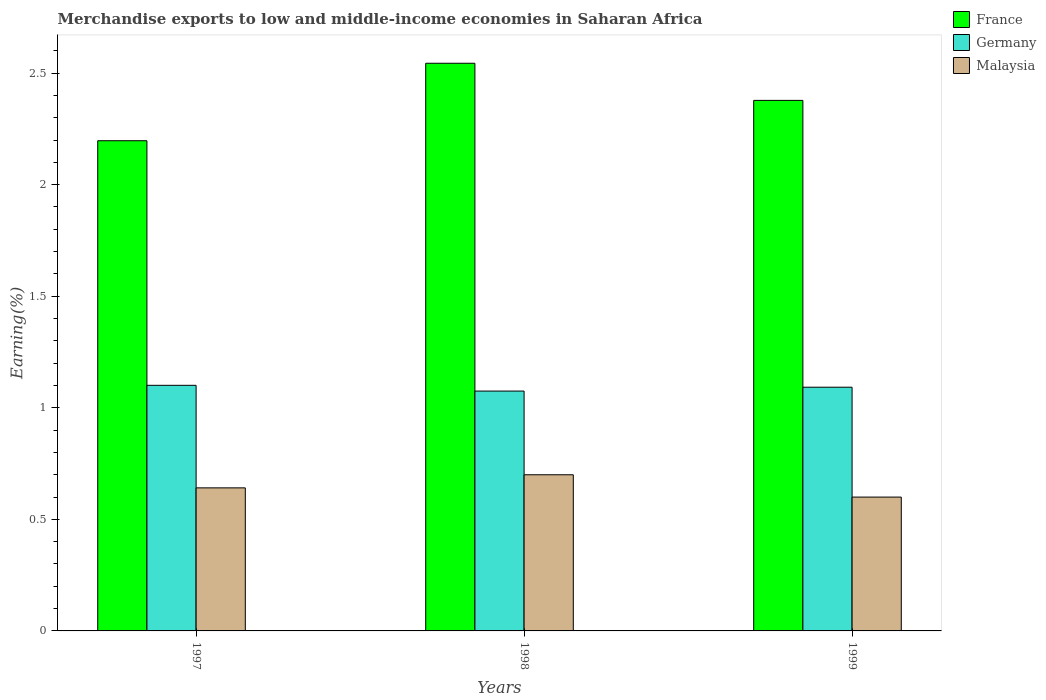How many different coloured bars are there?
Provide a succinct answer. 3. How many groups of bars are there?
Offer a very short reply. 3. Are the number of bars per tick equal to the number of legend labels?
Provide a succinct answer. Yes. How many bars are there on the 2nd tick from the right?
Make the answer very short. 3. What is the label of the 1st group of bars from the left?
Offer a terse response. 1997. What is the percentage of amount earned from merchandise exports in Malaysia in 1999?
Give a very brief answer. 0.6. Across all years, what is the maximum percentage of amount earned from merchandise exports in Malaysia?
Make the answer very short. 0.7. Across all years, what is the minimum percentage of amount earned from merchandise exports in France?
Your answer should be compact. 2.2. In which year was the percentage of amount earned from merchandise exports in Malaysia maximum?
Provide a succinct answer. 1998. In which year was the percentage of amount earned from merchandise exports in Germany minimum?
Your response must be concise. 1998. What is the total percentage of amount earned from merchandise exports in Germany in the graph?
Provide a short and direct response. 3.27. What is the difference between the percentage of amount earned from merchandise exports in Malaysia in 1997 and that in 1998?
Offer a very short reply. -0.06. What is the difference between the percentage of amount earned from merchandise exports in Germany in 1998 and the percentage of amount earned from merchandise exports in Malaysia in 1999?
Ensure brevity in your answer.  0.48. What is the average percentage of amount earned from merchandise exports in France per year?
Give a very brief answer. 2.37. In the year 1997, what is the difference between the percentage of amount earned from merchandise exports in Malaysia and percentage of amount earned from merchandise exports in France?
Your response must be concise. -1.56. What is the ratio of the percentage of amount earned from merchandise exports in France in 1997 to that in 1999?
Your response must be concise. 0.92. Is the percentage of amount earned from merchandise exports in Germany in 1997 less than that in 1999?
Ensure brevity in your answer.  No. What is the difference between the highest and the second highest percentage of amount earned from merchandise exports in Malaysia?
Provide a succinct answer. 0.06. What is the difference between the highest and the lowest percentage of amount earned from merchandise exports in France?
Your response must be concise. 0.35. What does the 3rd bar from the left in 1999 represents?
Your response must be concise. Malaysia. What does the 1st bar from the right in 1997 represents?
Give a very brief answer. Malaysia. Is it the case that in every year, the sum of the percentage of amount earned from merchandise exports in Germany and percentage of amount earned from merchandise exports in France is greater than the percentage of amount earned from merchandise exports in Malaysia?
Give a very brief answer. Yes. How are the legend labels stacked?
Give a very brief answer. Vertical. What is the title of the graph?
Your response must be concise. Merchandise exports to low and middle-income economies in Saharan Africa. Does "Panama" appear as one of the legend labels in the graph?
Your response must be concise. No. What is the label or title of the Y-axis?
Your answer should be compact. Earning(%). What is the Earning(%) in France in 1997?
Your response must be concise. 2.2. What is the Earning(%) in Germany in 1997?
Give a very brief answer. 1.1. What is the Earning(%) in Malaysia in 1997?
Your answer should be compact. 0.64. What is the Earning(%) of France in 1998?
Offer a terse response. 2.54. What is the Earning(%) of Germany in 1998?
Ensure brevity in your answer.  1.07. What is the Earning(%) of Malaysia in 1998?
Offer a very short reply. 0.7. What is the Earning(%) of France in 1999?
Make the answer very short. 2.38. What is the Earning(%) of Germany in 1999?
Provide a succinct answer. 1.09. What is the Earning(%) in Malaysia in 1999?
Provide a short and direct response. 0.6. Across all years, what is the maximum Earning(%) of France?
Your answer should be compact. 2.54. Across all years, what is the maximum Earning(%) in Germany?
Keep it short and to the point. 1.1. Across all years, what is the maximum Earning(%) in Malaysia?
Your response must be concise. 0.7. Across all years, what is the minimum Earning(%) of France?
Offer a terse response. 2.2. Across all years, what is the minimum Earning(%) of Germany?
Your answer should be very brief. 1.07. Across all years, what is the minimum Earning(%) of Malaysia?
Make the answer very short. 0.6. What is the total Earning(%) of France in the graph?
Ensure brevity in your answer.  7.12. What is the total Earning(%) in Germany in the graph?
Your response must be concise. 3.27. What is the total Earning(%) in Malaysia in the graph?
Your answer should be compact. 1.94. What is the difference between the Earning(%) of France in 1997 and that in 1998?
Keep it short and to the point. -0.35. What is the difference between the Earning(%) in Germany in 1997 and that in 1998?
Provide a short and direct response. 0.03. What is the difference between the Earning(%) in Malaysia in 1997 and that in 1998?
Offer a terse response. -0.06. What is the difference between the Earning(%) of France in 1997 and that in 1999?
Give a very brief answer. -0.18. What is the difference between the Earning(%) in Germany in 1997 and that in 1999?
Your answer should be compact. 0.01. What is the difference between the Earning(%) in Malaysia in 1997 and that in 1999?
Offer a terse response. 0.04. What is the difference between the Earning(%) of France in 1998 and that in 1999?
Offer a very short reply. 0.17. What is the difference between the Earning(%) in Germany in 1998 and that in 1999?
Provide a succinct answer. -0.02. What is the difference between the Earning(%) of Malaysia in 1998 and that in 1999?
Your answer should be compact. 0.1. What is the difference between the Earning(%) in France in 1997 and the Earning(%) in Germany in 1998?
Give a very brief answer. 1.12. What is the difference between the Earning(%) in France in 1997 and the Earning(%) in Malaysia in 1998?
Provide a short and direct response. 1.5. What is the difference between the Earning(%) of Germany in 1997 and the Earning(%) of Malaysia in 1998?
Keep it short and to the point. 0.4. What is the difference between the Earning(%) of France in 1997 and the Earning(%) of Germany in 1999?
Ensure brevity in your answer.  1.1. What is the difference between the Earning(%) in France in 1997 and the Earning(%) in Malaysia in 1999?
Make the answer very short. 1.6. What is the difference between the Earning(%) of Germany in 1997 and the Earning(%) of Malaysia in 1999?
Offer a terse response. 0.5. What is the difference between the Earning(%) of France in 1998 and the Earning(%) of Germany in 1999?
Ensure brevity in your answer.  1.45. What is the difference between the Earning(%) in France in 1998 and the Earning(%) in Malaysia in 1999?
Your answer should be very brief. 1.94. What is the difference between the Earning(%) in Germany in 1998 and the Earning(%) in Malaysia in 1999?
Give a very brief answer. 0.48. What is the average Earning(%) in France per year?
Provide a succinct answer. 2.37. What is the average Earning(%) of Germany per year?
Give a very brief answer. 1.09. What is the average Earning(%) in Malaysia per year?
Your response must be concise. 0.65. In the year 1997, what is the difference between the Earning(%) in France and Earning(%) in Germany?
Provide a short and direct response. 1.1. In the year 1997, what is the difference between the Earning(%) in France and Earning(%) in Malaysia?
Offer a terse response. 1.56. In the year 1997, what is the difference between the Earning(%) in Germany and Earning(%) in Malaysia?
Ensure brevity in your answer.  0.46. In the year 1998, what is the difference between the Earning(%) of France and Earning(%) of Germany?
Make the answer very short. 1.47. In the year 1998, what is the difference between the Earning(%) in France and Earning(%) in Malaysia?
Offer a terse response. 1.84. In the year 1998, what is the difference between the Earning(%) of Germany and Earning(%) of Malaysia?
Keep it short and to the point. 0.38. In the year 1999, what is the difference between the Earning(%) of France and Earning(%) of Germany?
Provide a succinct answer. 1.29. In the year 1999, what is the difference between the Earning(%) of France and Earning(%) of Malaysia?
Keep it short and to the point. 1.78. In the year 1999, what is the difference between the Earning(%) in Germany and Earning(%) in Malaysia?
Keep it short and to the point. 0.49. What is the ratio of the Earning(%) of France in 1997 to that in 1998?
Your answer should be compact. 0.86. What is the ratio of the Earning(%) of Germany in 1997 to that in 1998?
Your answer should be very brief. 1.02. What is the ratio of the Earning(%) in Malaysia in 1997 to that in 1998?
Ensure brevity in your answer.  0.92. What is the ratio of the Earning(%) of France in 1997 to that in 1999?
Provide a short and direct response. 0.92. What is the ratio of the Earning(%) of Germany in 1997 to that in 1999?
Your response must be concise. 1.01. What is the ratio of the Earning(%) of Malaysia in 1997 to that in 1999?
Your answer should be very brief. 1.07. What is the ratio of the Earning(%) of France in 1998 to that in 1999?
Your answer should be very brief. 1.07. What is the ratio of the Earning(%) of Germany in 1998 to that in 1999?
Keep it short and to the point. 0.98. What is the ratio of the Earning(%) of Malaysia in 1998 to that in 1999?
Offer a terse response. 1.17. What is the difference between the highest and the second highest Earning(%) in France?
Offer a very short reply. 0.17. What is the difference between the highest and the second highest Earning(%) in Germany?
Make the answer very short. 0.01. What is the difference between the highest and the second highest Earning(%) in Malaysia?
Your response must be concise. 0.06. What is the difference between the highest and the lowest Earning(%) in France?
Provide a succinct answer. 0.35. What is the difference between the highest and the lowest Earning(%) of Germany?
Ensure brevity in your answer.  0.03. What is the difference between the highest and the lowest Earning(%) of Malaysia?
Make the answer very short. 0.1. 